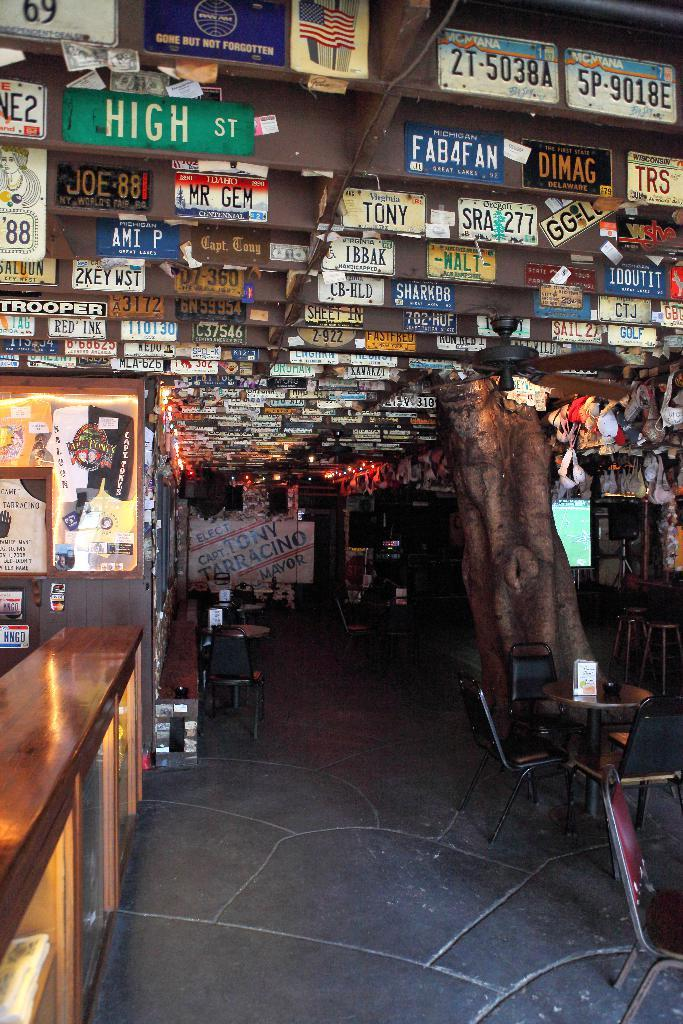Provide a one-sentence caption for the provided image. A restaurant with a lot of signs on the ceiling one says high st. 